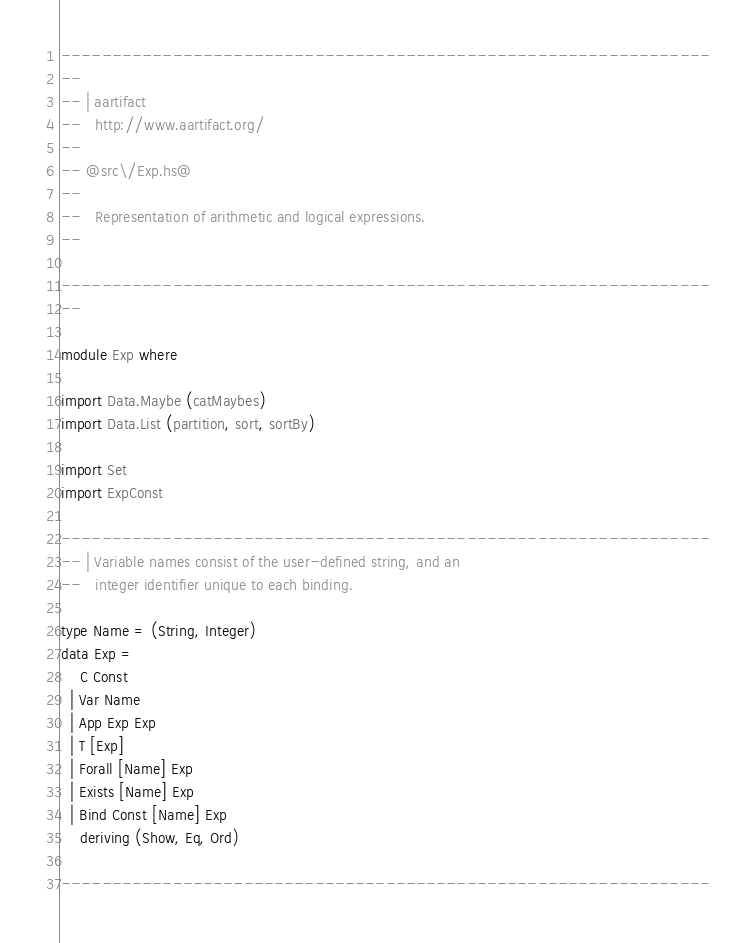Convert code to text. <code><loc_0><loc_0><loc_500><loc_500><_Haskell_>----------------------------------------------------------------
--
-- | aartifact
--   http://www.aartifact.org/
--
-- @src\/Exp.hs@
--
--   Representation of arithmetic and logical expressions.
--

----------------------------------------------------------------
--

module Exp where

import Data.Maybe (catMaybes)
import Data.List (partition, sort, sortBy)

import Set
import ExpConst

----------------------------------------------------------------
-- | Variable names consist of the user-defined string, and an
--   integer identifier unique to each binding.

type Name = (String, Integer)
data Exp =
    C Const
  | Var Name
  | App Exp Exp
  | T [Exp]
  | Forall [Name] Exp
  | Exists [Name] Exp
  | Bind Const [Name] Exp
    deriving (Show, Eq, Ord)

----------------------------------------------------------------</code> 